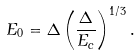<formula> <loc_0><loc_0><loc_500><loc_500>E _ { 0 } = \Delta \left ( \frac { \Delta } { E _ { c } } \right ) ^ { 1 / 3 } .</formula> 